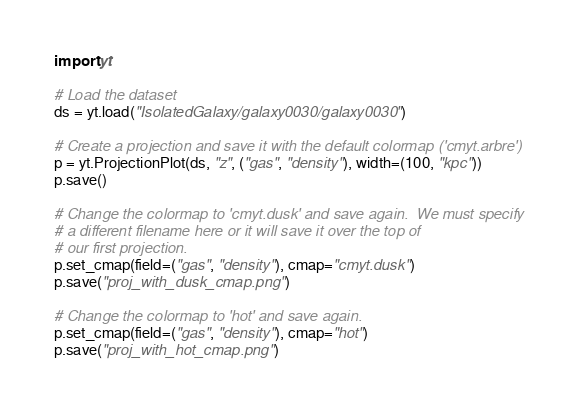Convert code to text. <code><loc_0><loc_0><loc_500><loc_500><_Python_>import yt

# Load the dataset
ds = yt.load("IsolatedGalaxy/galaxy0030/galaxy0030")

# Create a projection and save it with the default colormap ('cmyt.arbre')
p = yt.ProjectionPlot(ds, "z", ("gas", "density"), width=(100, "kpc"))
p.save()

# Change the colormap to 'cmyt.dusk' and save again.  We must specify
# a different filename here or it will save it over the top of
# our first projection.
p.set_cmap(field=("gas", "density"), cmap="cmyt.dusk")
p.save("proj_with_dusk_cmap.png")

# Change the colormap to 'hot' and save again.
p.set_cmap(field=("gas", "density"), cmap="hot")
p.save("proj_with_hot_cmap.png")
</code> 